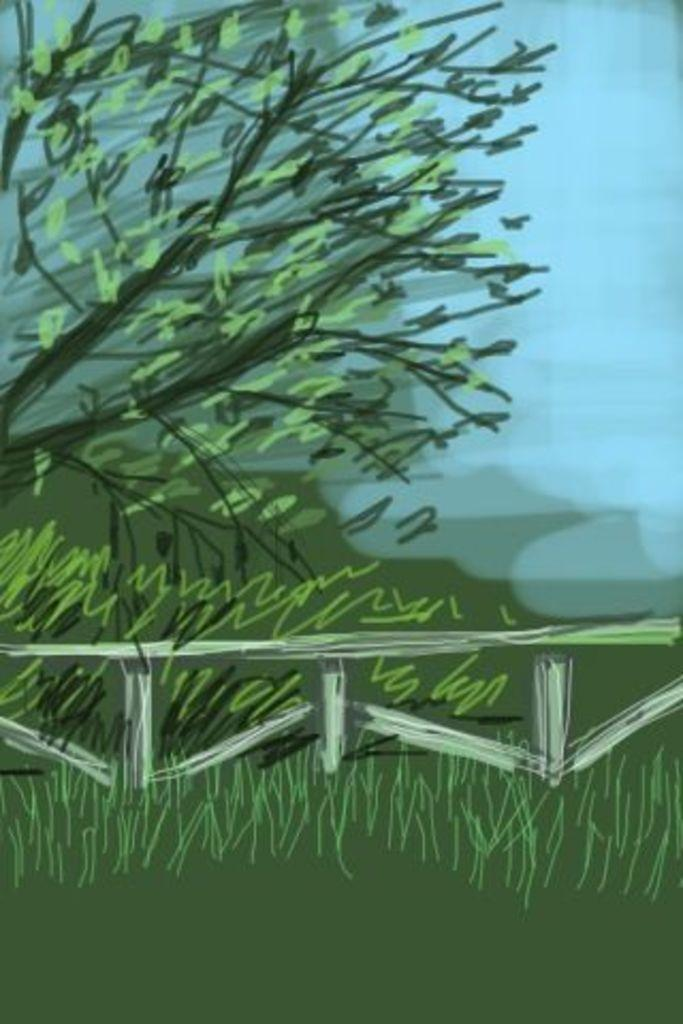What is the main subject of the image? There is a colorful sketch in the image. Can you describe the sketch in more detail? Unfortunately, the facts provided do not give any specific details about the sketch. However, we can say that it is colorful. What type of alley is visible in the background of the sketch? There is no alley present in the image, as the image only contains a colorful sketch. 